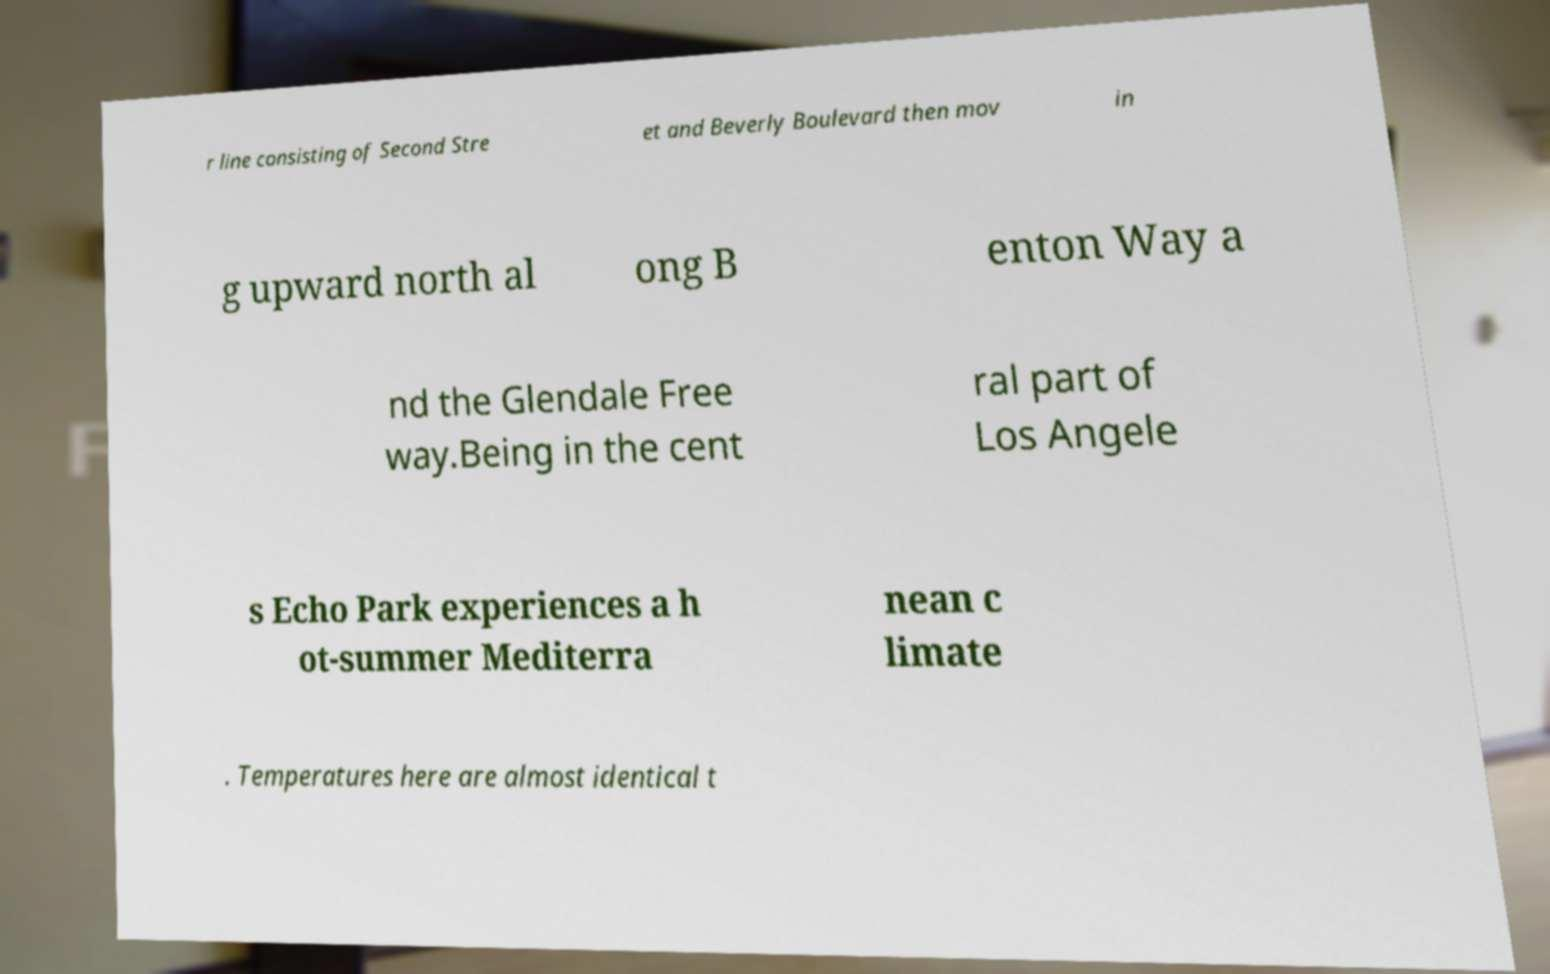Could you extract and type out the text from this image? r line consisting of Second Stre et and Beverly Boulevard then mov in g upward north al ong B enton Way a nd the Glendale Free way.Being in the cent ral part of Los Angele s Echo Park experiences a h ot-summer Mediterra nean c limate . Temperatures here are almost identical t 